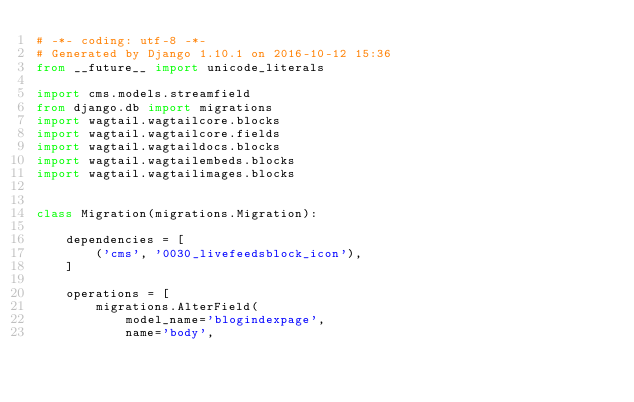<code> <loc_0><loc_0><loc_500><loc_500><_Python_># -*- coding: utf-8 -*-
# Generated by Django 1.10.1 on 2016-10-12 15:36
from __future__ import unicode_literals

import cms.models.streamfield
from django.db import migrations
import wagtail.wagtailcore.blocks
import wagtail.wagtailcore.fields
import wagtail.wagtaildocs.blocks
import wagtail.wagtailembeds.blocks
import wagtail.wagtailimages.blocks


class Migration(migrations.Migration):

    dependencies = [
        ('cms', '0030_livefeedsblock_icon'),
    ]

    operations = [
        migrations.AlterField(
            model_name='blogindexpage',
            name='body',</code> 